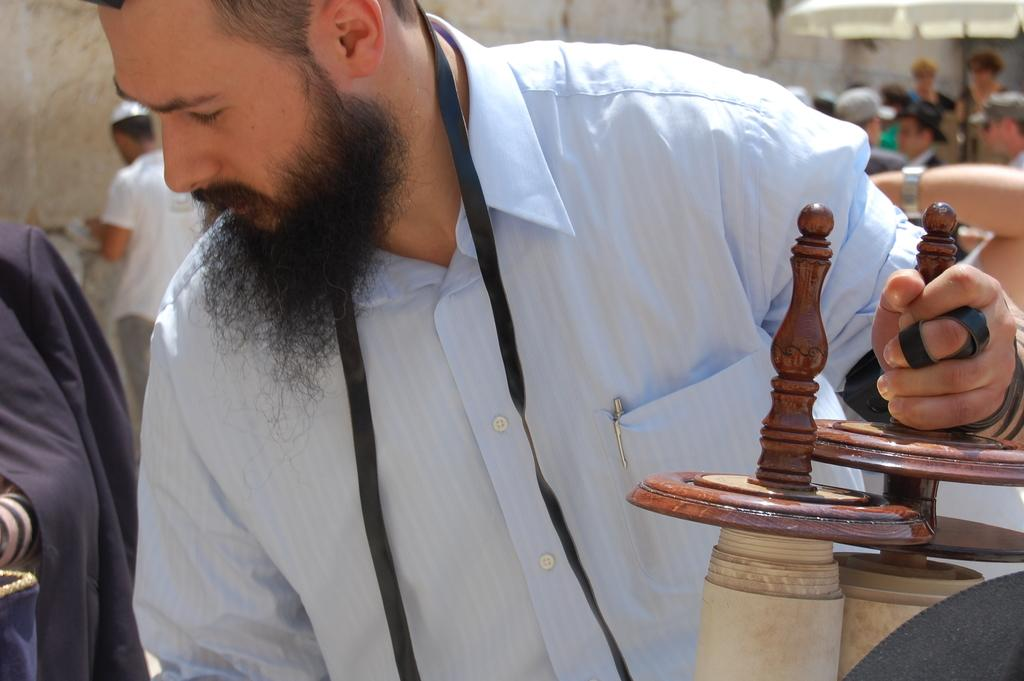What is the person in the image holding? The person in the image is holding a wooden object. Can you describe the setting of the image? There are other people visible in the background of the image. What color is the sky in the image? There is no mention of the sky in the provided facts, so we cannot determine its color from the image. 